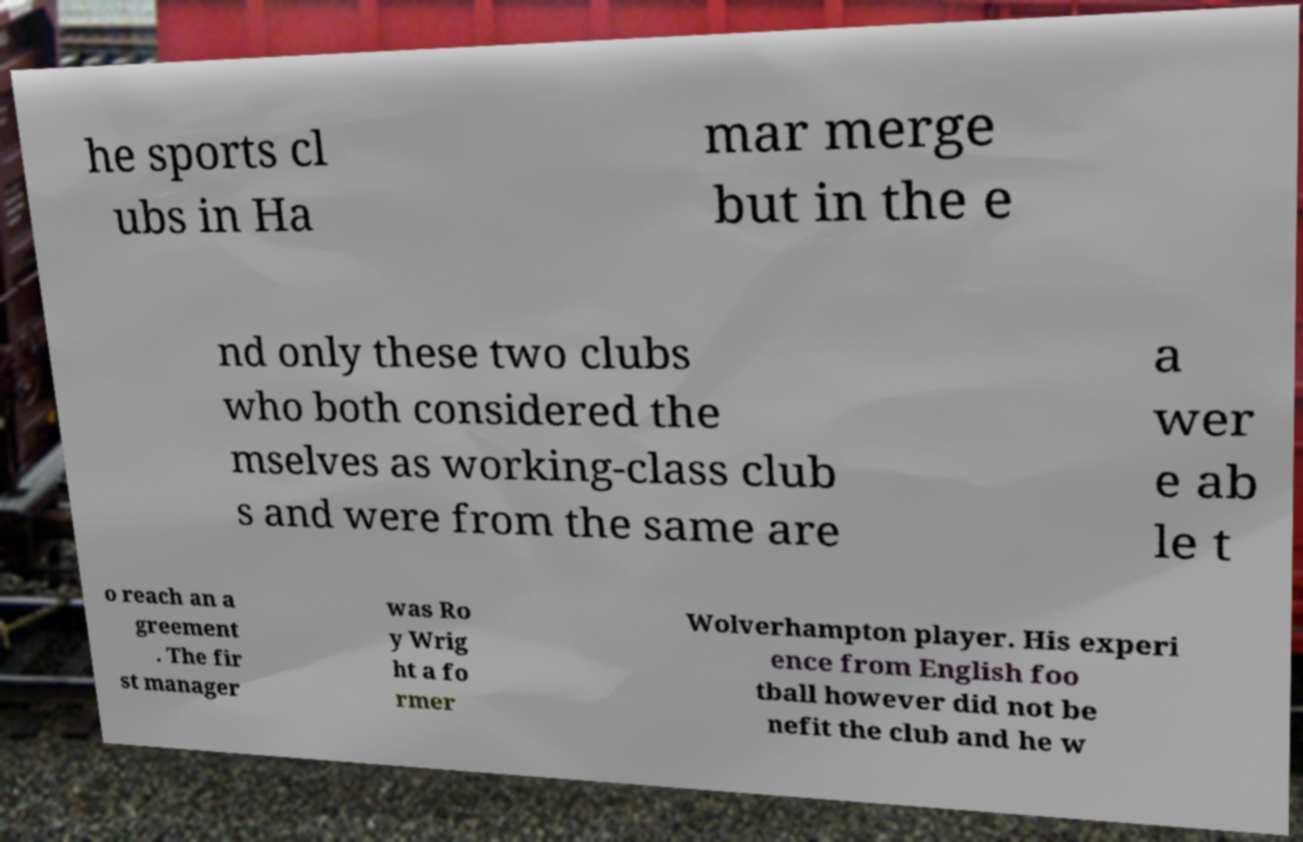Can you accurately transcribe the text from the provided image for me? he sports cl ubs in Ha mar merge but in the e nd only these two clubs who both considered the mselves as working-class club s and were from the same are a wer e ab le t o reach an a greement . The fir st manager was Ro y Wrig ht a fo rmer Wolverhampton player. His experi ence from English foo tball however did not be nefit the club and he w 